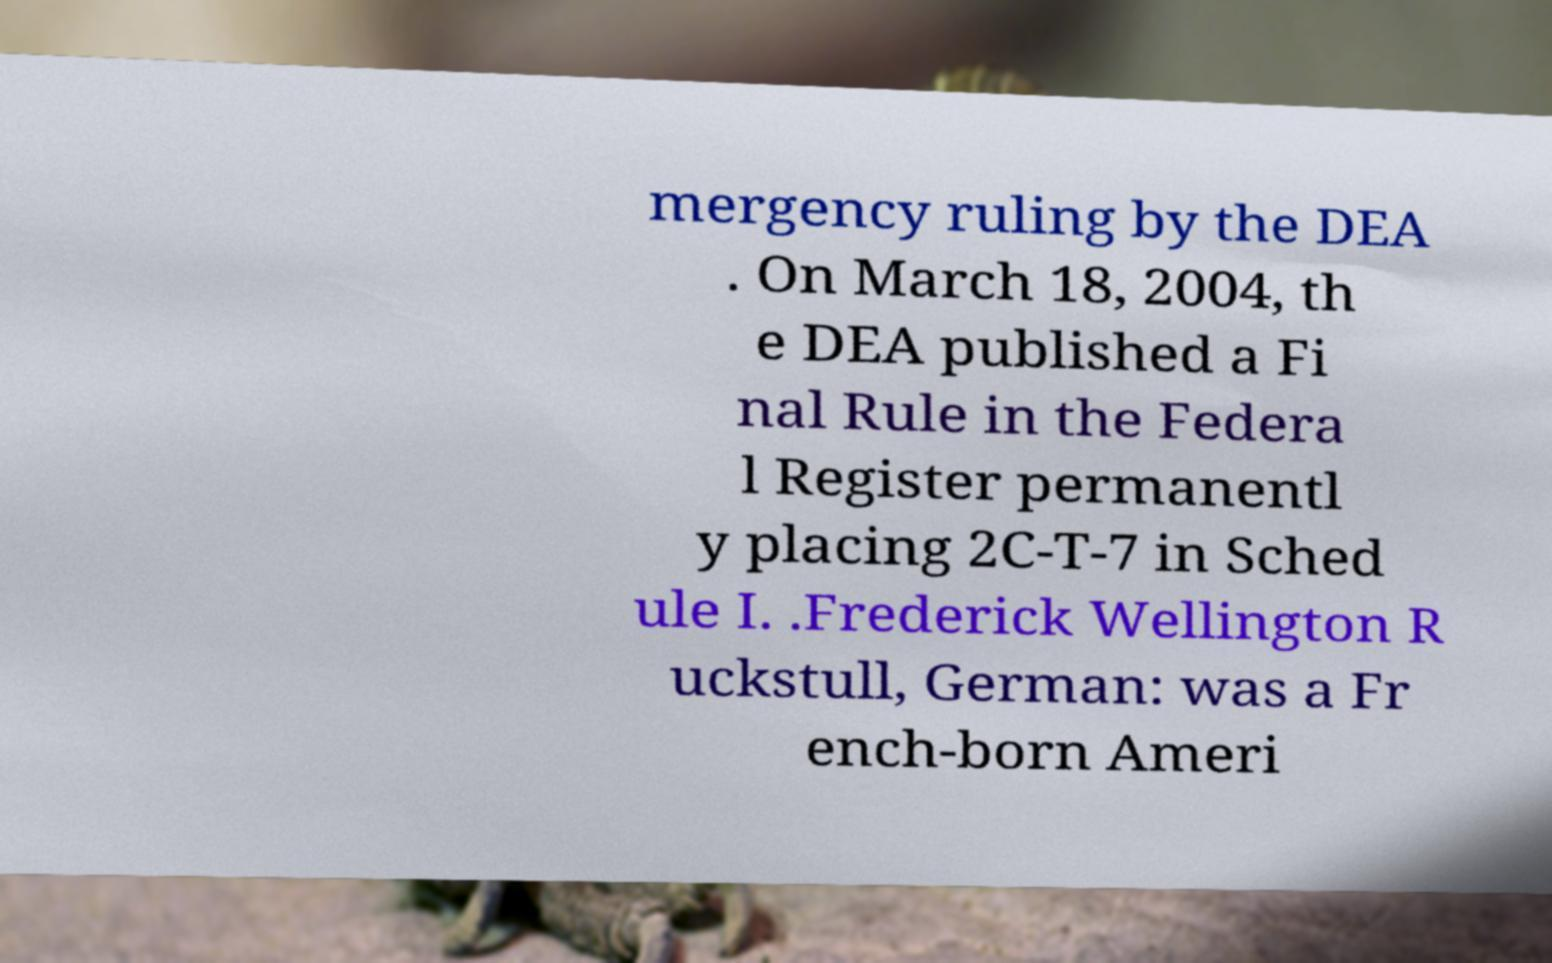Can you accurately transcribe the text from the provided image for me? mergency ruling by the DEA . On March 18, 2004, th e DEA published a Fi nal Rule in the Federa l Register permanentl y placing 2C-T-7 in Sched ule I. .Frederick Wellington R uckstull, German: was a Fr ench-born Ameri 